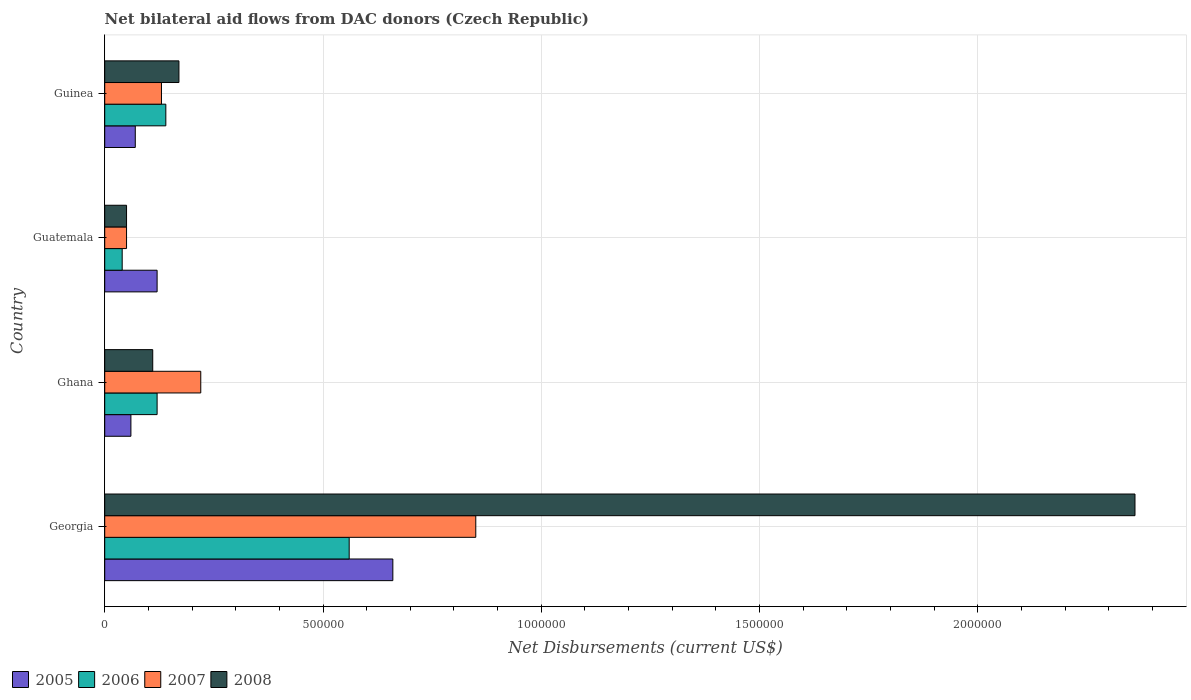Are the number of bars per tick equal to the number of legend labels?
Keep it short and to the point. Yes. Are the number of bars on each tick of the Y-axis equal?
Provide a succinct answer. Yes. How many bars are there on the 4th tick from the top?
Your answer should be very brief. 4. What is the label of the 3rd group of bars from the top?
Make the answer very short. Ghana. In how many cases, is the number of bars for a given country not equal to the number of legend labels?
Your answer should be compact. 0. What is the net bilateral aid flows in 2006 in Guatemala?
Your response must be concise. 4.00e+04. Across all countries, what is the maximum net bilateral aid flows in 2007?
Your answer should be very brief. 8.50e+05. In which country was the net bilateral aid flows in 2008 maximum?
Make the answer very short. Georgia. What is the total net bilateral aid flows in 2008 in the graph?
Provide a short and direct response. 2.69e+06. What is the difference between the net bilateral aid flows in 2006 in Ghana and the net bilateral aid flows in 2008 in Guatemala?
Your answer should be very brief. 7.00e+04. What is the average net bilateral aid flows in 2007 per country?
Your response must be concise. 3.12e+05. What is the difference between the net bilateral aid flows in 2007 and net bilateral aid flows in 2008 in Ghana?
Ensure brevity in your answer.  1.10e+05. What is the ratio of the net bilateral aid flows in 2006 in Guatemala to that in Guinea?
Your answer should be very brief. 0.29. What is the difference between the highest and the second highest net bilateral aid flows in 2007?
Provide a short and direct response. 6.30e+05. What is the difference between the highest and the lowest net bilateral aid flows in 2006?
Provide a succinct answer. 5.20e+05. In how many countries, is the net bilateral aid flows in 2005 greater than the average net bilateral aid flows in 2005 taken over all countries?
Give a very brief answer. 1. What does the 3rd bar from the top in Georgia represents?
Offer a very short reply. 2006. Is it the case that in every country, the sum of the net bilateral aid flows in 2008 and net bilateral aid flows in 2005 is greater than the net bilateral aid flows in 2007?
Provide a short and direct response. No. How many bars are there?
Provide a succinct answer. 16. Are all the bars in the graph horizontal?
Your response must be concise. Yes. Does the graph contain any zero values?
Provide a short and direct response. No. What is the title of the graph?
Ensure brevity in your answer.  Net bilateral aid flows from DAC donors (Czech Republic). What is the label or title of the X-axis?
Your response must be concise. Net Disbursements (current US$). What is the label or title of the Y-axis?
Offer a terse response. Country. What is the Net Disbursements (current US$) of 2006 in Georgia?
Ensure brevity in your answer.  5.60e+05. What is the Net Disbursements (current US$) of 2007 in Georgia?
Your answer should be very brief. 8.50e+05. What is the Net Disbursements (current US$) in 2008 in Georgia?
Your answer should be compact. 2.36e+06. What is the Net Disbursements (current US$) in 2008 in Ghana?
Your answer should be compact. 1.10e+05. What is the Net Disbursements (current US$) of 2005 in Guatemala?
Your answer should be very brief. 1.20e+05. What is the Net Disbursements (current US$) in 2006 in Guatemala?
Give a very brief answer. 4.00e+04. What is the Net Disbursements (current US$) of 2008 in Guatemala?
Offer a terse response. 5.00e+04. What is the Net Disbursements (current US$) in 2005 in Guinea?
Offer a very short reply. 7.00e+04. What is the Net Disbursements (current US$) in 2006 in Guinea?
Your answer should be very brief. 1.40e+05. What is the Net Disbursements (current US$) in 2007 in Guinea?
Keep it short and to the point. 1.30e+05. What is the Net Disbursements (current US$) in 2008 in Guinea?
Offer a very short reply. 1.70e+05. Across all countries, what is the maximum Net Disbursements (current US$) in 2006?
Make the answer very short. 5.60e+05. Across all countries, what is the maximum Net Disbursements (current US$) of 2007?
Provide a short and direct response. 8.50e+05. Across all countries, what is the maximum Net Disbursements (current US$) in 2008?
Keep it short and to the point. 2.36e+06. Across all countries, what is the minimum Net Disbursements (current US$) of 2005?
Your answer should be very brief. 6.00e+04. Across all countries, what is the minimum Net Disbursements (current US$) of 2006?
Your response must be concise. 4.00e+04. Across all countries, what is the minimum Net Disbursements (current US$) of 2008?
Your response must be concise. 5.00e+04. What is the total Net Disbursements (current US$) in 2005 in the graph?
Provide a succinct answer. 9.10e+05. What is the total Net Disbursements (current US$) in 2006 in the graph?
Offer a terse response. 8.60e+05. What is the total Net Disbursements (current US$) in 2007 in the graph?
Give a very brief answer. 1.25e+06. What is the total Net Disbursements (current US$) in 2008 in the graph?
Provide a succinct answer. 2.69e+06. What is the difference between the Net Disbursements (current US$) in 2005 in Georgia and that in Ghana?
Your answer should be very brief. 6.00e+05. What is the difference between the Net Disbursements (current US$) of 2007 in Georgia and that in Ghana?
Offer a very short reply. 6.30e+05. What is the difference between the Net Disbursements (current US$) in 2008 in Georgia and that in Ghana?
Offer a terse response. 2.25e+06. What is the difference between the Net Disbursements (current US$) in 2005 in Georgia and that in Guatemala?
Your answer should be very brief. 5.40e+05. What is the difference between the Net Disbursements (current US$) of 2006 in Georgia and that in Guatemala?
Offer a terse response. 5.20e+05. What is the difference between the Net Disbursements (current US$) in 2008 in Georgia and that in Guatemala?
Your response must be concise. 2.31e+06. What is the difference between the Net Disbursements (current US$) of 2005 in Georgia and that in Guinea?
Provide a short and direct response. 5.90e+05. What is the difference between the Net Disbursements (current US$) in 2006 in Georgia and that in Guinea?
Make the answer very short. 4.20e+05. What is the difference between the Net Disbursements (current US$) of 2007 in Georgia and that in Guinea?
Your response must be concise. 7.20e+05. What is the difference between the Net Disbursements (current US$) in 2008 in Georgia and that in Guinea?
Your answer should be very brief. 2.19e+06. What is the difference between the Net Disbursements (current US$) of 2005 in Ghana and that in Guatemala?
Your response must be concise. -6.00e+04. What is the difference between the Net Disbursements (current US$) in 2007 in Ghana and that in Guatemala?
Offer a terse response. 1.70e+05. What is the difference between the Net Disbursements (current US$) in 2005 in Ghana and that in Guinea?
Your answer should be very brief. -10000. What is the difference between the Net Disbursements (current US$) in 2008 in Ghana and that in Guinea?
Make the answer very short. -6.00e+04. What is the difference between the Net Disbursements (current US$) in 2007 in Guatemala and that in Guinea?
Keep it short and to the point. -8.00e+04. What is the difference between the Net Disbursements (current US$) in 2008 in Guatemala and that in Guinea?
Make the answer very short. -1.20e+05. What is the difference between the Net Disbursements (current US$) in 2005 in Georgia and the Net Disbursements (current US$) in 2006 in Ghana?
Provide a succinct answer. 5.40e+05. What is the difference between the Net Disbursements (current US$) of 2005 in Georgia and the Net Disbursements (current US$) of 2007 in Ghana?
Provide a succinct answer. 4.40e+05. What is the difference between the Net Disbursements (current US$) of 2006 in Georgia and the Net Disbursements (current US$) of 2007 in Ghana?
Make the answer very short. 3.40e+05. What is the difference between the Net Disbursements (current US$) in 2006 in Georgia and the Net Disbursements (current US$) in 2008 in Ghana?
Make the answer very short. 4.50e+05. What is the difference between the Net Disbursements (current US$) of 2007 in Georgia and the Net Disbursements (current US$) of 2008 in Ghana?
Make the answer very short. 7.40e+05. What is the difference between the Net Disbursements (current US$) in 2005 in Georgia and the Net Disbursements (current US$) in 2006 in Guatemala?
Offer a terse response. 6.20e+05. What is the difference between the Net Disbursements (current US$) in 2006 in Georgia and the Net Disbursements (current US$) in 2007 in Guatemala?
Keep it short and to the point. 5.10e+05. What is the difference between the Net Disbursements (current US$) in 2006 in Georgia and the Net Disbursements (current US$) in 2008 in Guatemala?
Provide a short and direct response. 5.10e+05. What is the difference between the Net Disbursements (current US$) of 2005 in Georgia and the Net Disbursements (current US$) of 2006 in Guinea?
Ensure brevity in your answer.  5.20e+05. What is the difference between the Net Disbursements (current US$) in 2005 in Georgia and the Net Disbursements (current US$) in 2007 in Guinea?
Offer a terse response. 5.30e+05. What is the difference between the Net Disbursements (current US$) in 2005 in Georgia and the Net Disbursements (current US$) in 2008 in Guinea?
Your response must be concise. 4.90e+05. What is the difference between the Net Disbursements (current US$) of 2007 in Georgia and the Net Disbursements (current US$) of 2008 in Guinea?
Your response must be concise. 6.80e+05. What is the difference between the Net Disbursements (current US$) in 2005 in Ghana and the Net Disbursements (current US$) in 2008 in Guatemala?
Provide a succinct answer. 10000. What is the difference between the Net Disbursements (current US$) of 2006 in Ghana and the Net Disbursements (current US$) of 2007 in Guatemala?
Ensure brevity in your answer.  7.00e+04. What is the difference between the Net Disbursements (current US$) of 2005 in Ghana and the Net Disbursements (current US$) of 2006 in Guinea?
Make the answer very short. -8.00e+04. What is the difference between the Net Disbursements (current US$) of 2006 in Ghana and the Net Disbursements (current US$) of 2007 in Guinea?
Your answer should be very brief. -10000. What is the difference between the Net Disbursements (current US$) of 2005 in Guatemala and the Net Disbursements (current US$) of 2006 in Guinea?
Provide a short and direct response. -2.00e+04. What is the difference between the Net Disbursements (current US$) in 2006 in Guatemala and the Net Disbursements (current US$) in 2008 in Guinea?
Make the answer very short. -1.30e+05. What is the difference between the Net Disbursements (current US$) of 2007 in Guatemala and the Net Disbursements (current US$) of 2008 in Guinea?
Keep it short and to the point. -1.20e+05. What is the average Net Disbursements (current US$) of 2005 per country?
Your answer should be very brief. 2.28e+05. What is the average Net Disbursements (current US$) of 2006 per country?
Offer a terse response. 2.15e+05. What is the average Net Disbursements (current US$) of 2007 per country?
Ensure brevity in your answer.  3.12e+05. What is the average Net Disbursements (current US$) of 2008 per country?
Your answer should be compact. 6.72e+05. What is the difference between the Net Disbursements (current US$) of 2005 and Net Disbursements (current US$) of 2006 in Georgia?
Your answer should be very brief. 1.00e+05. What is the difference between the Net Disbursements (current US$) in 2005 and Net Disbursements (current US$) in 2008 in Georgia?
Your answer should be compact. -1.70e+06. What is the difference between the Net Disbursements (current US$) of 2006 and Net Disbursements (current US$) of 2008 in Georgia?
Provide a short and direct response. -1.80e+06. What is the difference between the Net Disbursements (current US$) of 2007 and Net Disbursements (current US$) of 2008 in Georgia?
Offer a terse response. -1.51e+06. What is the difference between the Net Disbursements (current US$) of 2005 and Net Disbursements (current US$) of 2006 in Ghana?
Your answer should be very brief. -6.00e+04. What is the difference between the Net Disbursements (current US$) of 2005 and Net Disbursements (current US$) of 2007 in Ghana?
Give a very brief answer. -1.60e+05. What is the difference between the Net Disbursements (current US$) of 2005 and Net Disbursements (current US$) of 2008 in Ghana?
Give a very brief answer. -5.00e+04. What is the difference between the Net Disbursements (current US$) of 2005 and Net Disbursements (current US$) of 2007 in Guatemala?
Make the answer very short. 7.00e+04. What is the difference between the Net Disbursements (current US$) of 2005 and Net Disbursements (current US$) of 2008 in Guatemala?
Give a very brief answer. 7.00e+04. What is the difference between the Net Disbursements (current US$) of 2006 and Net Disbursements (current US$) of 2007 in Guatemala?
Your answer should be very brief. -10000. What is the difference between the Net Disbursements (current US$) of 2005 and Net Disbursements (current US$) of 2006 in Guinea?
Ensure brevity in your answer.  -7.00e+04. What is the difference between the Net Disbursements (current US$) of 2005 and Net Disbursements (current US$) of 2007 in Guinea?
Give a very brief answer. -6.00e+04. What is the difference between the Net Disbursements (current US$) in 2005 and Net Disbursements (current US$) in 2008 in Guinea?
Provide a short and direct response. -1.00e+05. What is the difference between the Net Disbursements (current US$) in 2006 and Net Disbursements (current US$) in 2007 in Guinea?
Your answer should be very brief. 10000. What is the difference between the Net Disbursements (current US$) in 2007 and Net Disbursements (current US$) in 2008 in Guinea?
Your response must be concise. -4.00e+04. What is the ratio of the Net Disbursements (current US$) in 2005 in Georgia to that in Ghana?
Give a very brief answer. 11. What is the ratio of the Net Disbursements (current US$) of 2006 in Georgia to that in Ghana?
Ensure brevity in your answer.  4.67. What is the ratio of the Net Disbursements (current US$) of 2007 in Georgia to that in Ghana?
Offer a terse response. 3.86. What is the ratio of the Net Disbursements (current US$) of 2008 in Georgia to that in Ghana?
Your response must be concise. 21.45. What is the ratio of the Net Disbursements (current US$) in 2005 in Georgia to that in Guatemala?
Offer a terse response. 5.5. What is the ratio of the Net Disbursements (current US$) of 2008 in Georgia to that in Guatemala?
Provide a succinct answer. 47.2. What is the ratio of the Net Disbursements (current US$) in 2005 in Georgia to that in Guinea?
Offer a terse response. 9.43. What is the ratio of the Net Disbursements (current US$) in 2006 in Georgia to that in Guinea?
Your answer should be compact. 4. What is the ratio of the Net Disbursements (current US$) in 2007 in Georgia to that in Guinea?
Make the answer very short. 6.54. What is the ratio of the Net Disbursements (current US$) of 2008 in Georgia to that in Guinea?
Give a very brief answer. 13.88. What is the ratio of the Net Disbursements (current US$) of 2005 in Ghana to that in Guatemala?
Make the answer very short. 0.5. What is the ratio of the Net Disbursements (current US$) of 2007 in Ghana to that in Guatemala?
Ensure brevity in your answer.  4.4. What is the ratio of the Net Disbursements (current US$) of 2006 in Ghana to that in Guinea?
Ensure brevity in your answer.  0.86. What is the ratio of the Net Disbursements (current US$) in 2007 in Ghana to that in Guinea?
Your response must be concise. 1.69. What is the ratio of the Net Disbursements (current US$) in 2008 in Ghana to that in Guinea?
Make the answer very short. 0.65. What is the ratio of the Net Disbursements (current US$) in 2005 in Guatemala to that in Guinea?
Your answer should be compact. 1.71. What is the ratio of the Net Disbursements (current US$) of 2006 in Guatemala to that in Guinea?
Keep it short and to the point. 0.29. What is the ratio of the Net Disbursements (current US$) in 2007 in Guatemala to that in Guinea?
Your answer should be very brief. 0.38. What is the ratio of the Net Disbursements (current US$) in 2008 in Guatemala to that in Guinea?
Keep it short and to the point. 0.29. What is the difference between the highest and the second highest Net Disbursements (current US$) of 2005?
Your response must be concise. 5.40e+05. What is the difference between the highest and the second highest Net Disbursements (current US$) in 2007?
Provide a succinct answer. 6.30e+05. What is the difference between the highest and the second highest Net Disbursements (current US$) in 2008?
Your answer should be very brief. 2.19e+06. What is the difference between the highest and the lowest Net Disbursements (current US$) in 2006?
Offer a terse response. 5.20e+05. What is the difference between the highest and the lowest Net Disbursements (current US$) in 2007?
Your answer should be very brief. 8.00e+05. What is the difference between the highest and the lowest Net Disbursements (current US$) of 2008?
Your answer should be compact. 2.31e+06. 